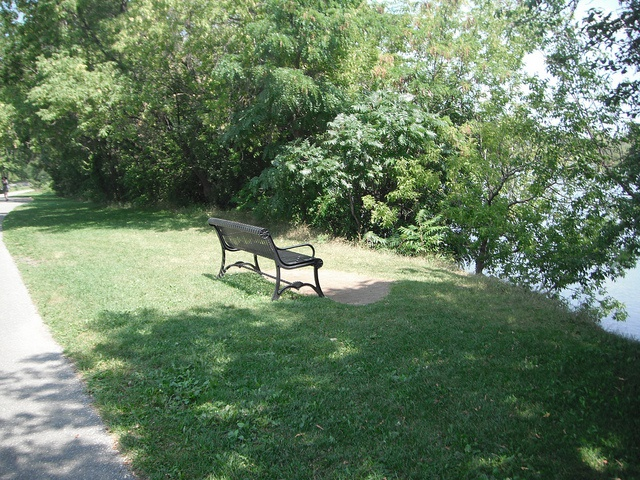Describe the objects in this image and their specific colors. I can see bench in green, gray, beige, and black tones and people in green, gray, darkgray, black, and lightgray tones in this image. 